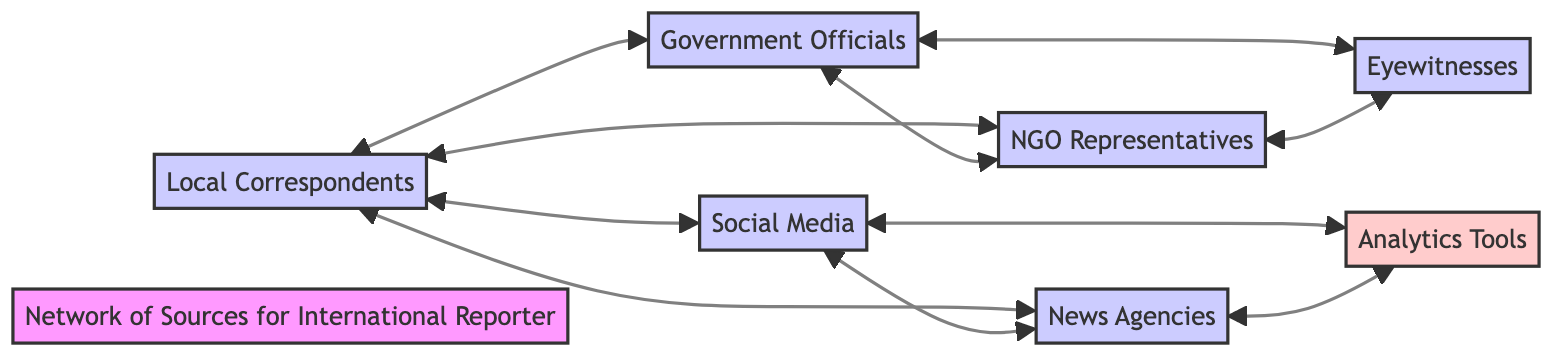What is the total number of sources in the network? The total number of sources is determined by counting all the blocks represented in the diagram. There are seven blocks: Local Correspondents, Government Officials, NGO Representatives, Social Media, News Agencies, Eyewitnesses, and Analytics Tools.
Answer: 7 Which block is connected to both News Agencies and Social Media? To find the block connected to both News Agencies and Social Media, we look for the intersections in their connections. Both are directly connected to Local Correspondents, which is the common block.
Answer: Local Correspondents How many direct connections does the Government Officials block have? By examining the connections listed for Government Officials, we see that it connects to Local Correspondents, NGO Representatives, and Eyewitnesses. This shows it has three direct connections.
Answer: 3 Which two sources directly share a connection with eyewitnesses? Eyewitnesses have direct connections with two sources: Government Officials and NGO Representatives. By checking the connections of the Eyewitnesses block, we can confirm this.
Answer: Government Officials and NGO Representatives How many blocks are there in total that connect to the Social Media block? To find the blocks that connect to Social Media, we examine its connections: Local Correspondents, News Agencies, and Analytics Tools. Counting these gives a total of three blocks connected to Social Media.
Answer: 3 Which blocks are connected to the Analytics Tools block? The Analytics Tools block is connected to both Social Media and News Agencies. This is confirmed by checking the connections listed for Analytics Tools.
Answer: Social Media and News Agencies What type of tools does the Analytics Tools block represent? The Analytics Tools block represents platforms used for verifying information and tracking trends. This information is found in the details section of the block.
Answer: Analytical platforms Which sources can provide first-hand accounts of events? The only source that provides first-hand accounts is Eyewitnesses, as indicated by its definition in the diagram.
Answer: Eyewitnesses How many edges are there between the blocks in the network? To count the edges, we tally each connection listed between the blocks. There are ten connections in total when summarized from the relationships.
Answer: 10 